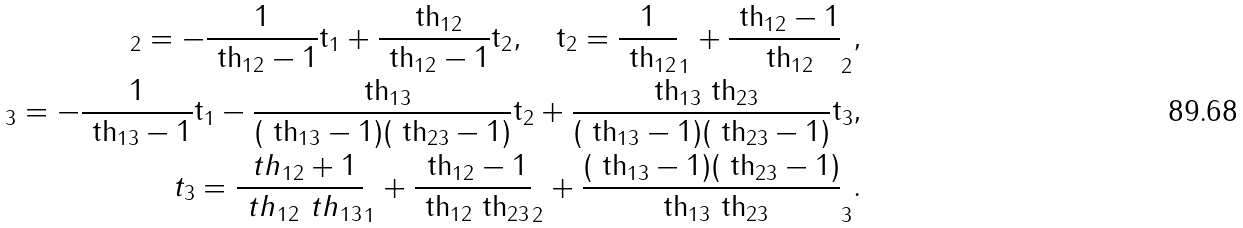Convert formula to latex. <formula><loc_0><loc_0><loc_500><loc_500>\tt _ { 2 } = - \frac { 1 } { \ t h _ { 1 2 } - 1 } t _ { 1 } + \frac { \ t h _ { 1 2 } } { \ t h _ { 1 2 } - 1 } t _ { 2 } , \quad t _ { 2 } = \frac { 1 } { \ t h _ { 1 2 } } \tt _ { 1 } + \frac { \ t h _ { 1 2 } - 1 } { \ t h _ { 1 2 } } \tt _ { 2 } , \\ \tt _ { 3 } = - \frac { 1 } { \ t h _ { 1 3 } - 1 } t _ { 1 } - \frac { \ t h _ { 1 3 } } { ( \ t h _ { 1 3 } - 1 ) ( \ t h _ { 2 3 } - 1 ) } t _ { 2 } + \frac { \ t h _ { 1 3 } \ t h _ { 2 3 } } { ( \ t h _ { 1 3 } - 1 ) ( \ t h _ { 2 3 } - 1 ) } t _ { 3 } , \\ t _ { 3 } = \frac { \ t h _ { 1 2 } + 1 } { \ t h _ { 1 2 } \ t h _ { 1 3 } } \tt _ { 1 } + \frac { \ t h _ { 1 2 } - 1 } { \ t h _ { 1 2 } \ t h _ { 2 3 } } \tt _ { 2 } + \frac { ( \ t h _ { 1 3 } - 1 ) ( \ t h _ { 2 3 } - 1 ) } { \ t h _ { 1 3 } \ t h _ { 2 3 } } \tt _ { 3 } .</formula> 